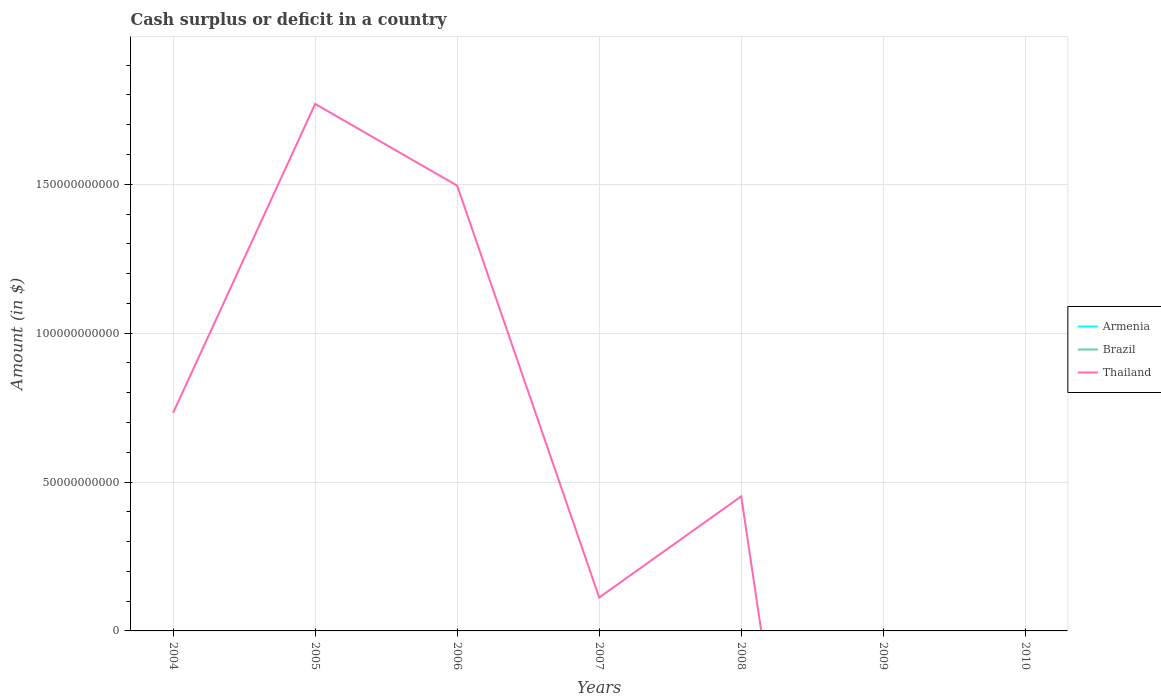Is the number of lines equal to the number of legend labels?
Your answer should be very brief. No. What is the total amount of cash surplus or deficit in Thailand in the graph?
Keep it short and to the point. -3.40e+1. What is the difference between the highest and the second highest amount of cash surplus or deficit in Thailand?
Your response must be concise. 1.77e+11. Is the amount of cash surplus or deficit in Thailand strictly greater than the amount of cash surplus or deficit in Brazil over the years?
Your answer should be compact. No. What is the difference between two consecutive major ticks on the Y-axis?
Ensure brevity in your answer.  5.00e+1. Are the values on the major ticks of Y-axis written in scientific E-notation?
Provide a short and direct response. No. Where does the legend appear in the graph?
Your answer should be compact. Center right. How are the legend labels stacked?
Give a very brief answer. Vertical. What is the title of the graph?
Keep it short and to the point. Cash surplus or deficit in a country. Does "Greenland" appear as one of the legend labels in the graph?
Offer a very short reply. No. What is the label or title of the X-axis?
Make the answer very short. Years. What is the label or title of the Y-axis?
Keep it short and to the point. Amount (in $). What is the Amount (in $) of Thailand in 2004?
Your answer should be very brief. 7.32e+1. What is the Amount (in $) of Brazil in 2005?
Provide a succinct answer. 0. What is the Amount (in $) in Thailand in 2005?
Keep it short and to the point. 1.77e+11. What is the Amount (in $) of Armenia in 2006?
Your response must be concise. 0. What is the Amount (in $) in Thailand in 2006?
Offer a very short reply. 1.50e+11. What is the Amount (in $) in Armenia in 2007?
Offer a terse response. 0. What is the Amount (in $) in Brazil in 2007?
Your response must be concise. 0. What is the Amount (in $) in Thailand in 2007?
Provide a succinct answer. 1.12e+1. What is the Amount (in $) in Armenia in 2008?
Give a very brief answer. 0. What is the Amount (in $) in Thailand in 2008?
Your response must be concise. 4.52e+1. What is the Amount (in $) in Thailand in 2010?
Your answer should be very brief. 0. Across all years, what is the maximum Amount (in $) of Thailand?
Offer a very short reply. 1.77e+11. Across all years, what is the minimum Amount (in $) in Thailand?
Offer a very short reply. 0. What is the total Amount (in $) of Thailand in the graph?
Ensure brevity in your answer.  4.56e+11. What is the difference between the Amount (in $) in Thailand in 2004 and that in 2005?
Keep it short and to the point. -1.04e+11. What is the difference between the Amount (in $) in Thailand in 2004 and that in 2006?
Provide a succinct answer. -7.63e+1. What is the difference between the Amount (in $) in Thailand in 2004 and that in 2007?
Provide a succinct answer. 6.20e+1. What is the difference between the Amount (in $) of Thailand in 2004 and that in 2008?
Your answer should be compact. 2.80e+1. What is the difference between the Amount (in $) of Thailand in 2005 and that in 2006?
Provide a short and direct response. 2.74e+1. What is the difference between the Amount (in $) of Thailand in 2005 and that in 2007?
Your response must be concise. 1.66e+11. What is the difference between the Amount (in $) of Thailand in 2005 and that in 2008?
Your response must be concise. 1.32e+11. What is the difference between the Amount (in $) of Thailand in 2006 and that in 2007?
Your answer should be very brief. 1.38e+11. What is the difference between the Amount (in $) of Thailand in 2006 and that in 2008?
Provide a short and direct response. 1.04e+11. What is the difference between the Amount (in $) in Thailand in 2007 and that in 2008?
Ensure brevity in your answer.  -3.40e+1. What is the average Amount (in $) of Armenia per year?
Provide a short and direct response. 0. What is the average Amount (in $) of Brazil per year?
Offer a terse response. 0. What is the average Amount (in $) in Thailand per year?
Offer a terse response. 6.52e+1. What is the ratio of the Amount (in $) of Thailand in 2004 to that in 2005?
Offer a very short reply. 0.41. What is the ratio of the Amount (in $) of Thailand in 2004 to that in 2006?
Offer a very short reply. 0.49. What is the ratio of the Amount (in $) in Thailand in 2004 to that in 2007?
Offer a terse response. 6.53. What is the ratio of the Amount (in $) in Thailand in 2004 to that in 2008?
Offer a very short reply. 1.62. What is the ratio of the Amount (in $) of Thailand in 2005 to that in 2006?
Make the answer very short. 1.18. What is the ratio of the Amount (in $) in Thailand in 2005 to that in 2007?
Offer a very short reply. 15.77. What is the ratio of the Amount (in $) in Thailand in 2005 to that in 2008?
Offer a very short reply. 3.92. What is the ratio of the Amount (in $) of Thailand in 2006 to that in 2007?
Provide a short and direct response. 13.33. What is the ratio of the Amount (in $) of Thailand in 2006 to that in 2008?
Ensure brevity in your answer.  3.31. What is the ratio of the Amount (in $) of Thailand in 2007 to that in 2008?
Your response must be concise. 0.25. What is the difference between the highest and the second highest Amount (in $) in Thailand?
Your answer should be very brief. 2.74e+1. What is the difference between the highest and the lowest Amount (in $) in Thailand?
Keep it short and to the point. 1.77e+11. 